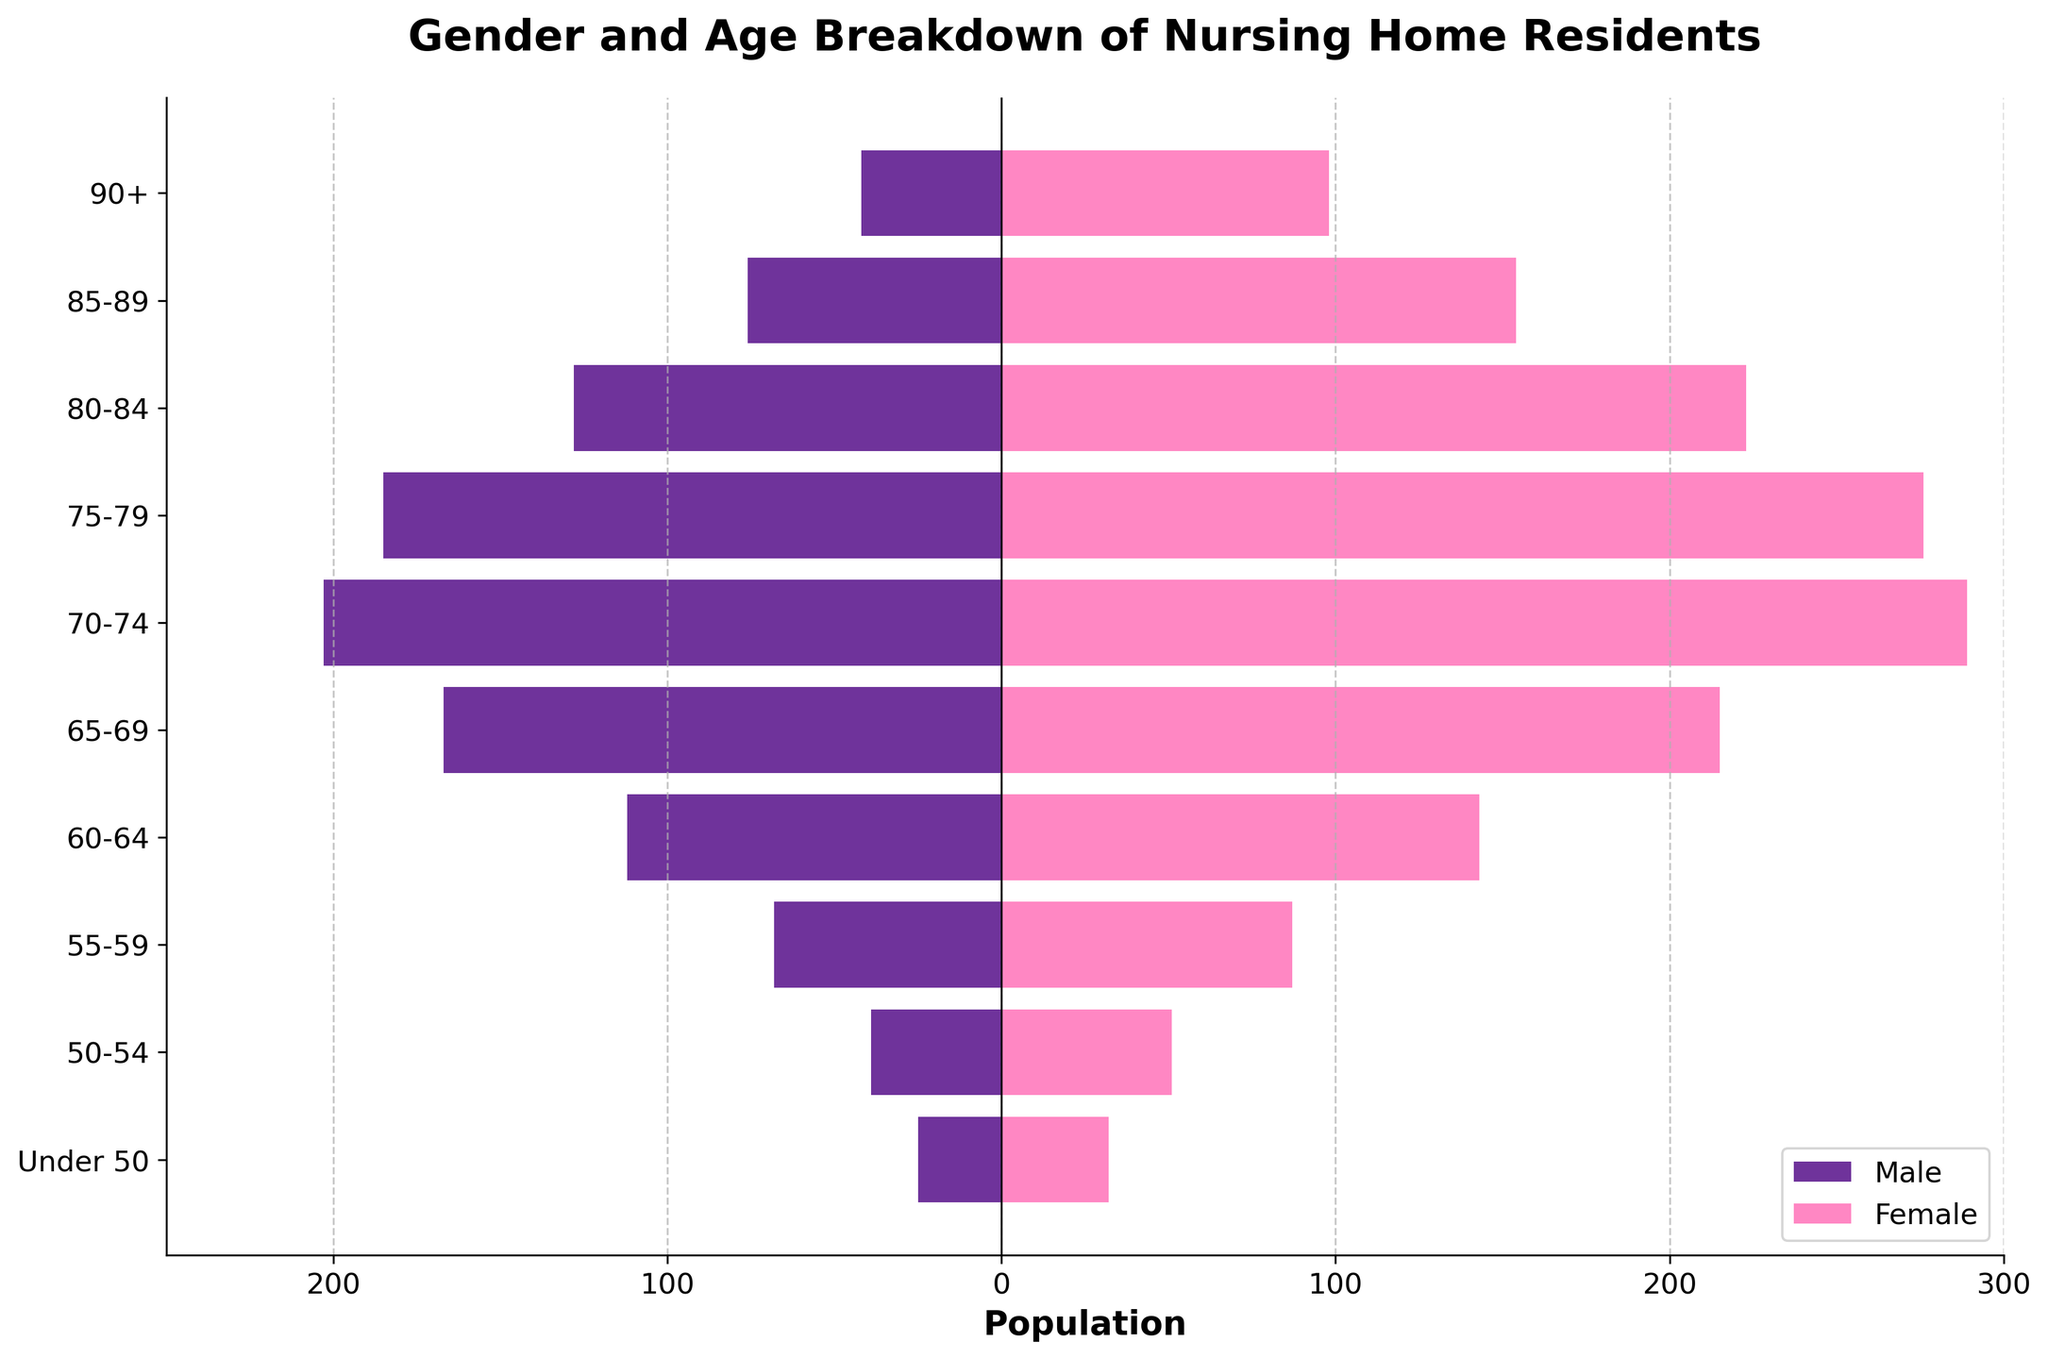What is the title of the plot? The title is usually located at the top of the figure and summarizes its content. In this plot, the title is "Gender and Age Breakdown of Nursing Home Residents".
Answer: Gender and Age Breakdown of Nursing Home Residents What is the age group with the largest male population? By examining the horizontal bars for males (on the left side of the zero line), the longest bar indicates the largest population. The age group "70-74" has the longest bar among males.
Answer: 70-74 Which gender has more residents in the age group 80-84? Looking at the bars for the age group "80-84", the female bar extends further to the right (higher population) than the male bar extends to the left.
Answer: Female What is the total number of residents in the age group 50-54? Add the male and female population for the age group "50-54". The male population is 39, and the female population is 51. The total is 39 + 51 = 90.
Answer: 90 How does the population of males aged 85-89 compare to females in the same age group? The male population for the age group "85-89" is 76, as shown by the length of the bar on the left. The female population in the same age group is 154, as shown by the bar on the right. Comparing them, the female population (154) is greater than the male population (76).
Answer: Females are more What is the range of the x-axis values? The x-axis values range from -250 to 300, allowing the plot to display both male and female populations clearly since male values are plotted as negative numbers.
Answer: -250 to 300 Which age group has the highest total population of residents? To find the group with the highest total population, sum the male and female values for each age group and compare them. The age group "75-79" has the highest combined population (185 males + 276 females = 461).
Answer: 75-79 What is the average number of female residents across all age groups? Calculate the average by summing up the female populations (98 + 154 + 223 + 276 + 289 + 215 + 143 + 87 + 51 + 32) and dividing by the number of age groups (10). Sum = 1568, Average = 1568 / 10 = 156.8.
Answer: 156.8 